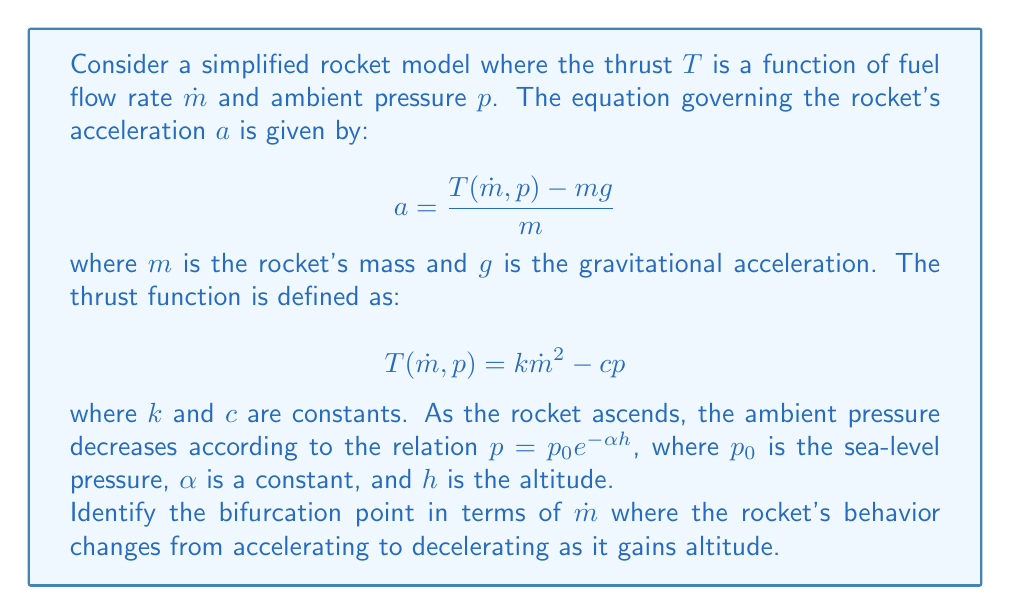Teach me how to tackle this problem. To solve this problem, we'll follow these steps:

1) First, we need to express the acceleration $a$ as a function of $\dot{m}$ and $h$:

   $$a = \frac{k\dot{m}^2 - cp_0e^{-\alpha h} - mg}{m}$$

2) At the bifurcation point, the acceleration will be zero and any change in altitude will cause a change in the direction of acceleration. So, we set $a = 0$:

   $$0 = \frac{k\dot{m}^2 - cp_0e^{-\alpha h} - mg}{m}$$

3) Solving for $\dot{m}$:

   $$k\dot{m}^2 = cp_0e^{-\alpha h} + mg$$
   $$\dot{m} = \sqrt{\frac{cp_0e^{-\alpha h} + mg}{k}}$$

4) Now, to find the bifurcation point, we need to find where this equation is tangent to the $h$-axis. This occurs when the derivative with respect to $h$ is zero:

   $$\frac{d\dot{m}}{dh} = -\frac{\alpha cp_0e^{-\alpha h}}{2k\sqrt{\frac{cp_0e^{-\alpha h} + mg}{k}}} = 0$$

5) This is true when $cp_0e^{-\alpha h} = 0$, which only occurs as $h \to \infty$. However, in practical terms, we can consider the bifurcation to occur when the pressure term becomes negligible compared to $mg$. Let's say this happens when $cp_0e^{-\alpha h} \leq \epsilon mg$, where $\epsilon$ is a small positive number.

6) Solving this inequality:

   $$cp_0e^{-\alpha h} \leq \epsilon mg$$
   $$e^{-\alpha h} \leq \frac{\epsilon mg}{cp_0}$$
   $$h \geq -\frac{1}{\alpha}\ln(\frac{\epsilon mg}{cp_0})$$

7) At this altitude, the bifurcation occurs. The corresponding $\dot{m}$ is:

   $$\dot{m} = \sqrt{\frac{cp_0(\frac{\epsilon mg}{cp_0}) + mg}{k}} = \sqrt{\frac{(1+\epsilon)mg}{k}}$$

This is the critical fuel flow rate at which the rocket's behavior changes from accelerating to decelerating as it gains altitude.
Answer: $$\dot{m}_{\text{critical}} = \sqrt{\frac{(1+\epsilon)mg}{k}}$$ 